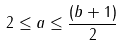<formula> <loc_0><loc_0><loc_500><loc_500>2 \leq a \leq \frac { ( b + 1 ) } { 2 }</formula> 